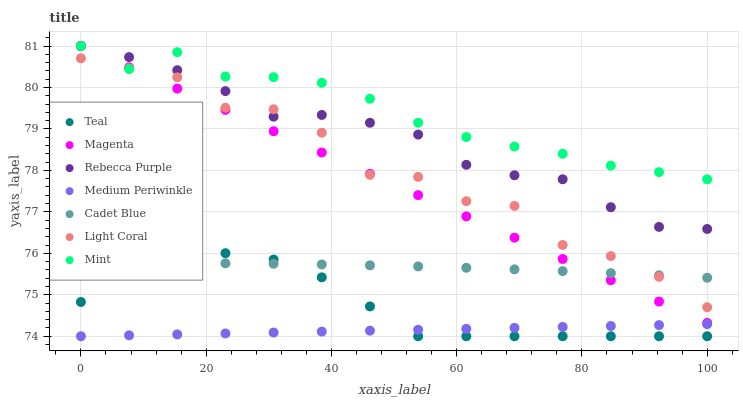Does Medium Periwinkle have the minimum area under the curve?
Answer yes or no. Yes. Does Mint have the maximum area under the curve?
Answer yes or no. Yes. Does Light Coral have the minimum area under the curve?
Answer yes or no. No. Does Light Coral have the maximum area under the curve?
Answer yes or no. No. Is Medium Periwinkle the smoothest?
Answer yes or no. Yes. Is Light Coral the roughest?
Answer yes or no. Yes. Is Light Coral the smoothest?
Answer yes or no. No. Is Medium Periwinkle the roughest?
Answer yes or no. No. Does Medium Periwinkle have the lowest value?
Answer yes or no. Yes. Does Light Coral have the lowest value?
Answer yes or no. No. Does Mint have the highest value?
Answer yes or no. Yes. Does Light Coral have the highest value?
Answer yes or no. No. Is Cadet Blue less than Rebecca Purple?
Answer yes or no. Yes. Is Magenta greater than Medium Periwinkle?
Answer yes or no. Yes. Does Cadet Blue intersect Light Coral?
Answer yes or no. Yes. Is Cadet Blue less than Light Coral?
Answer yes or no. No. Is Cadet Blue greater than Light Coral?
Answer yes or no. No. Does Cadet Blue intersect Rebecca Purple?
Answer yes or no. No. 